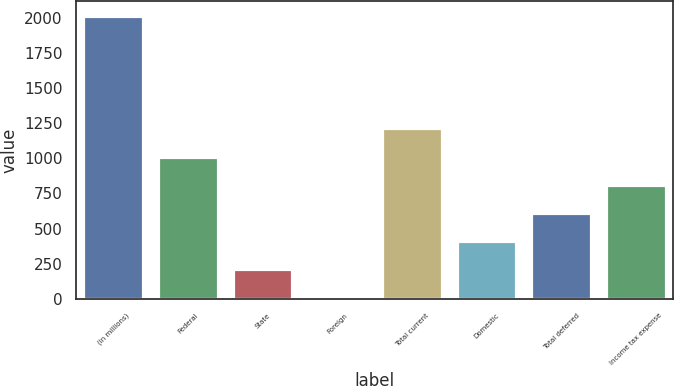<chart> <loc_0><loc_0><loc_500><loc_500><bar_chart><fcel>(in millions)<fcel>Federal<fcel>State<fcel>Foreign<fcel>Total current<fcel>Domestic<fcel>Total deferred<fcel>Income tax expense<nl><fcel>2015<fcel>1012.55<fcel>210.59<fcel>10.1<fcel>1213.04<fcel>411.08<fcel>611.57<fcel>812.06<nl></chart> 